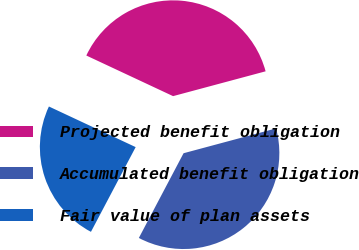<chart> <loc_0><loc_0><loc_500><loc_500><pie_chart><fcel>Projected benefit obligation<fcel>Accumulated benefit obligation<fcel>Fair value of plan assets<nl><fcel>38.86%<fcel>36.9%<fcel>24.24%<nl></chart> 